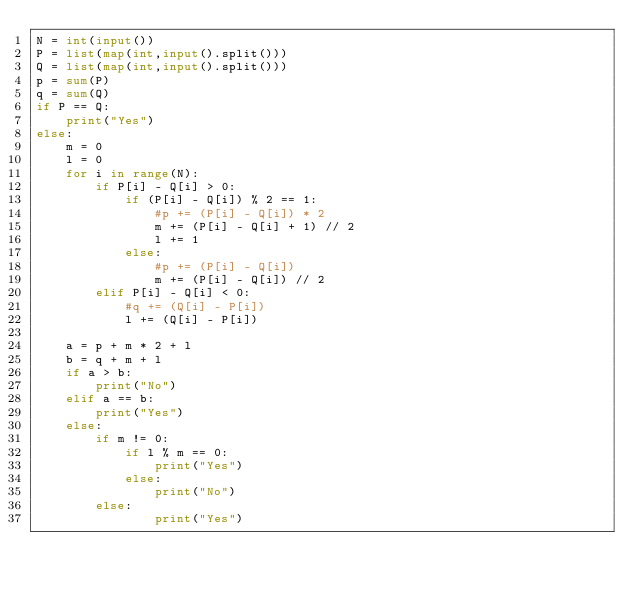Convert code to text. <code><loc_0><loc_0><loc_500><loc_500><_Python_>N = int(input())
P = list(map(int,input().split()))
Q = list(map(int,input().split()))
p = sum(P)
q = sum(Q)
if P == Q:
    print("Yes")
else:
    m = 0
    l = 0
    for i in range(N):
        if P[i] - Q[i] > 0:
            if (P[i] - Q[i]) % 2 == 1:
                #p += (P[i] - Q[i]) * 2
                m += (P[i] - Q[i] + 1) // 2
                l += 1
            else:
                #p += (P[i] - Q[i])
                m += (P[i] - Q[i]) // 2
        elif P[i] - Q[i] < 0:
            #q += (Q[i] - P[i])
            l += (Q[i] - P[i])
    
    a = p + m * 2 + l
    b = q + m + l 
    if a > b:
        print("No")
    elif a == b:
        print("Yes")
    else:
        if m != 0:
            if l % m == 0:
                print("Yes")
            else:
                print("No")
        else:
                print("Yes")</code> 